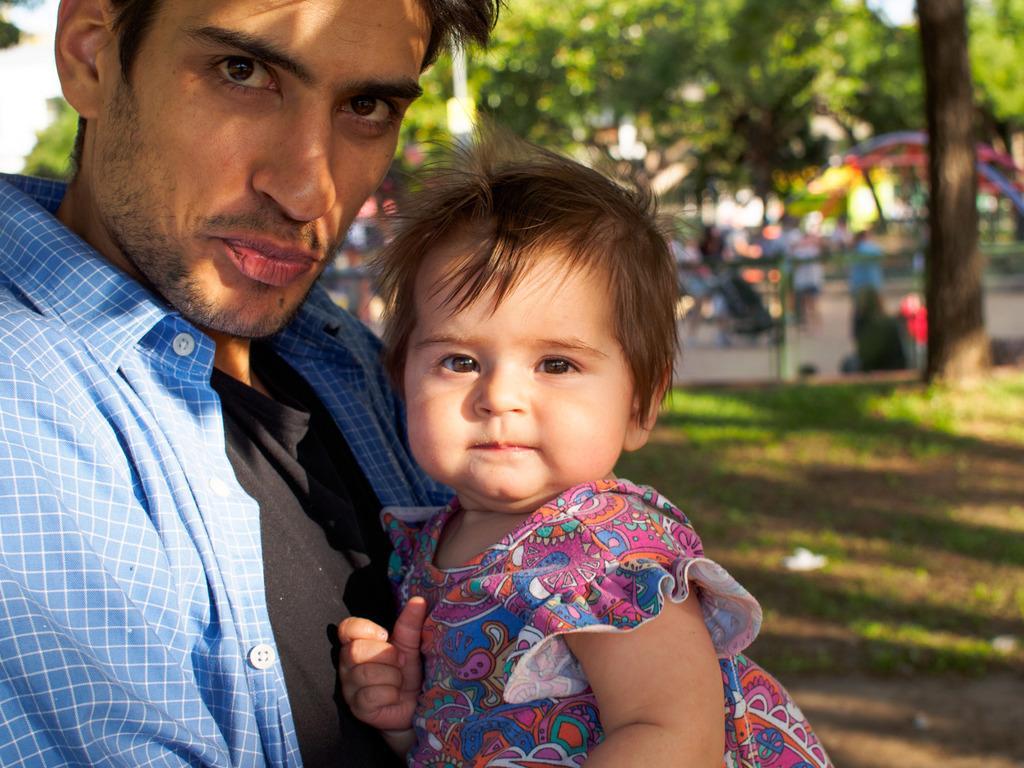Describe this image in one or two sentences. In the foreground of this image, there is a man carrying a girl in his hand. In the background there is the grass, tree and the remaining objects are unclear. 